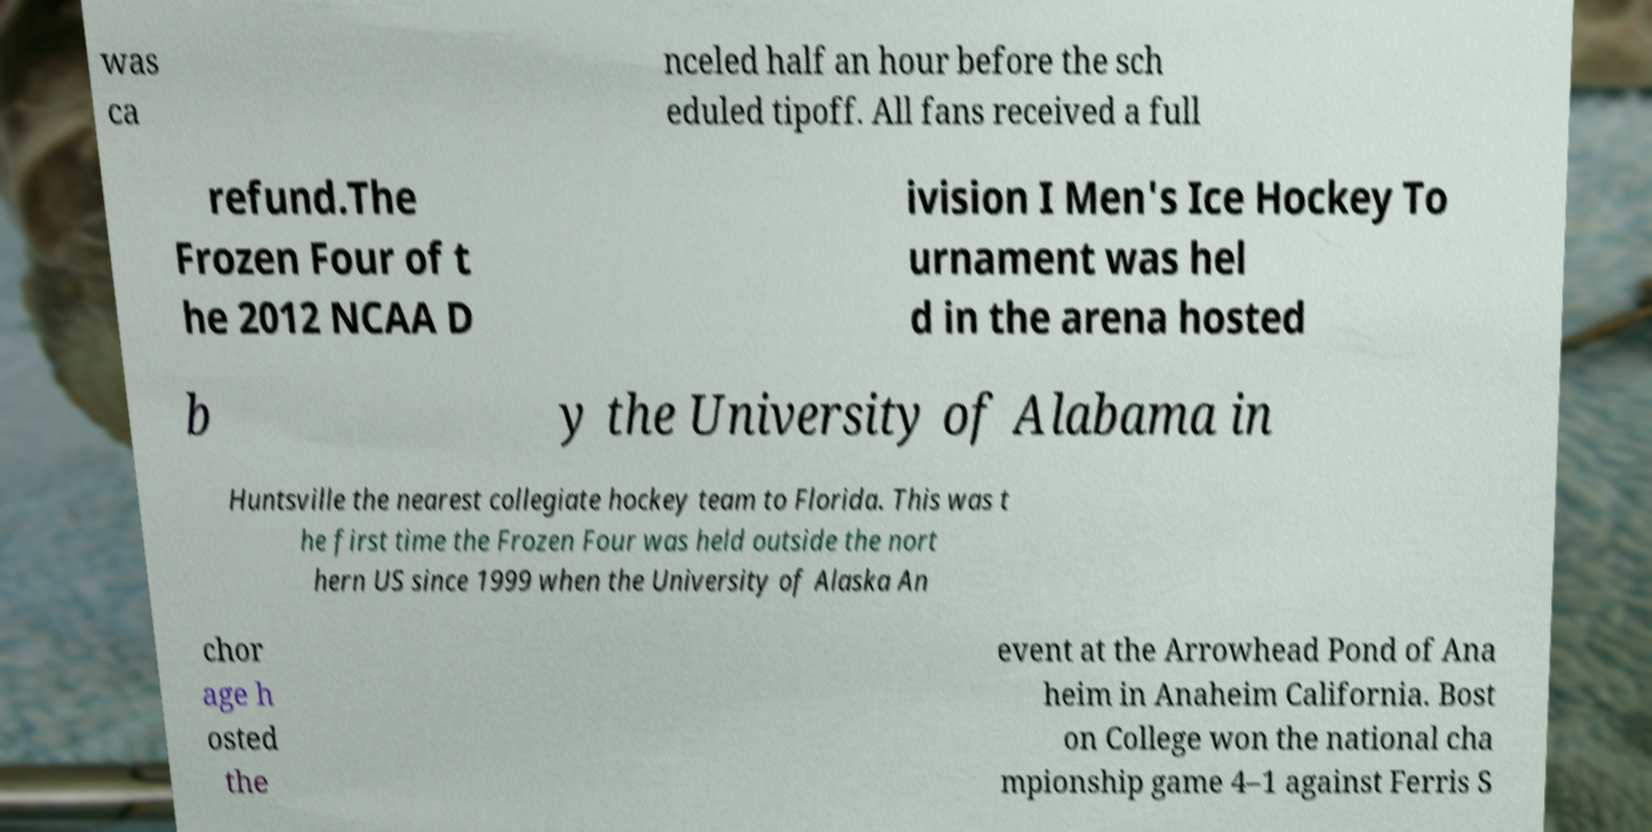Please read and relay the text visible in this image. What does it say? was ca nceled half an hour before the sch eduled tipoff. All fans received a full refund.The Frozen Four of t he 2012 NCAA D ivision I Men's Ice Hockey To urnament was hel d in the arena hosted b y the University of Alabama in Huntsville the nearest collegiate hockey team to Florida. This was t he first time the Frozen Four was held outside the nort hern US since 1999 when the University of Alaska An chor age h osted the event at the Arrowhead Pond of Ana heim in Anaheim California. Bost on College won the national cha mpionship game 4–1 against Ferris S 